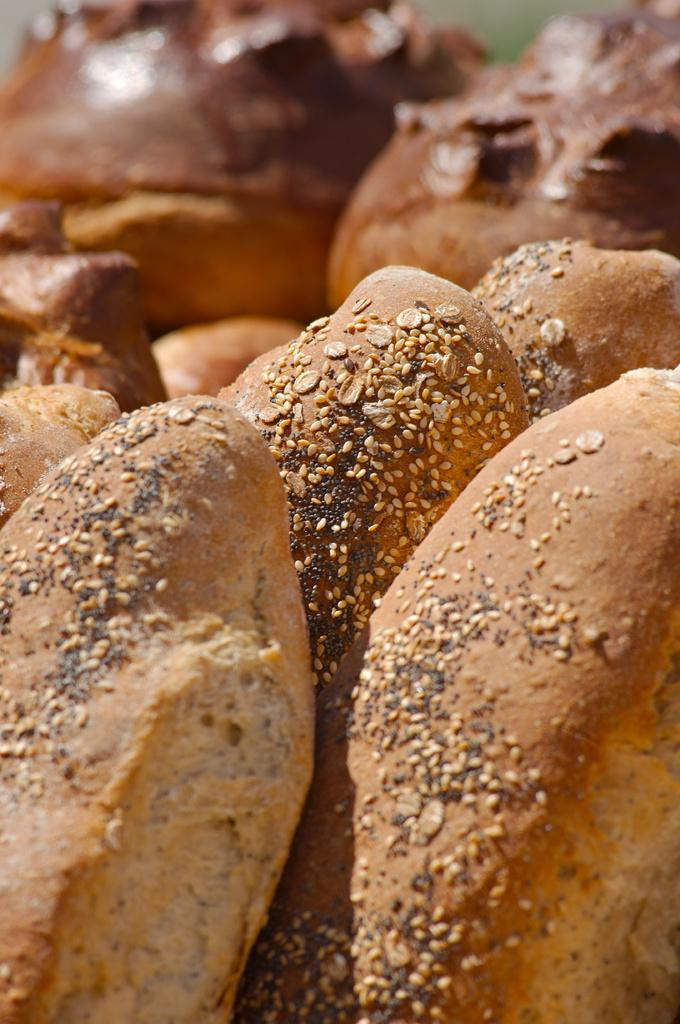What type of food can be seen in the image? There are eatables in the image that resemble doughnuts. Can you describe the background of the image? The background of the image is blurred. What temperature is the dinner being served at in the image? There is no dinner present in the image, and therefore no temperature can be determined. 